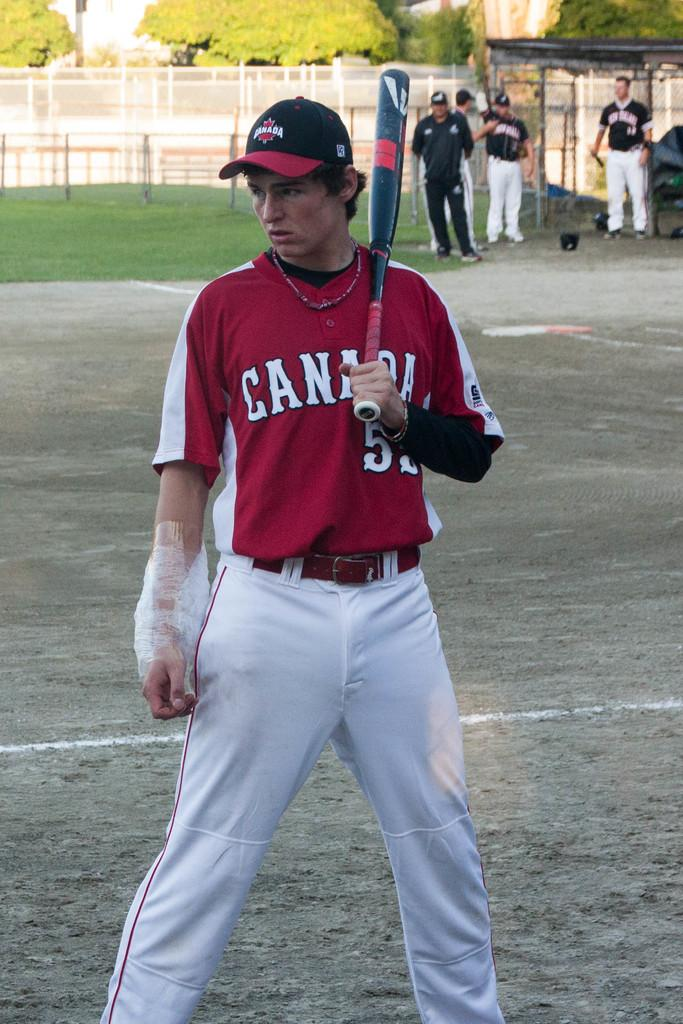<image>
Create a compact narrative representing the image presented. A Canada man is up to bat wearing his red jersey 